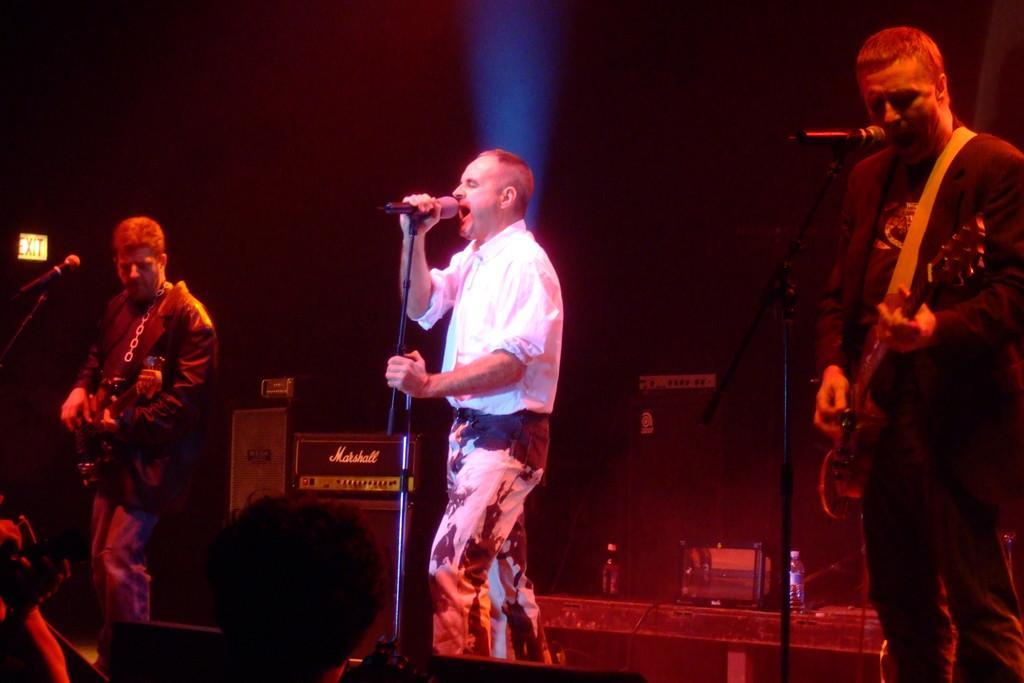Can you describe this image briefly? In this image we can see three people are standing on the stage, two of them are playing guitars and there are mics in front of them and a person is holding a mic and there are bottles and few objects in the background and there is an exit board on the left side. 